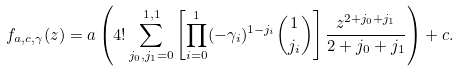<formula> <loc_0><loc_0><loc_500><loc_500>f _ { a , c , \gamma } ( z ) = a \left ( 4 ! \sum _ { j _ { 0 } , j _ { 1 } = 0 } ^ { 1 , 1 } \left [ \prod _ { i = 0 } ^ { 1 } ( - \gamma _ { i } ) ^ { 1 - j _ { i } } \binom { 1 } { j _ { i } } \right ] \frac { z ^ { 2 + j _ { 0 } + j _ { 1 } } } { 2 + j _ { 0 } + j _ { 1 } } \right ) + c .</formula> 